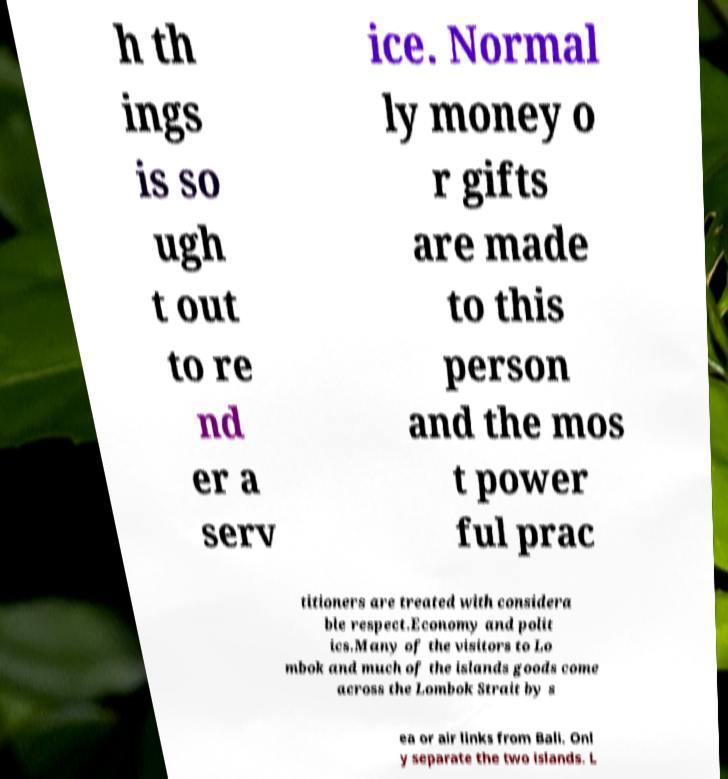Can you read and provide the text displayed in the image?This photo seems to have some interesting text. Can you extract and type it out for me? h th ings is so ugh t out to re nd er a serv ice. Normal ly money o r gifts are made to this person and the mos t power ful prac titioners are treated with considera ble respect.Economy and polit ics.Many of the visitors to Lo mbok and much of the islands goods come across the Lombok Strait by s ea or air links from Bali. Onl y separate the two islands. L 